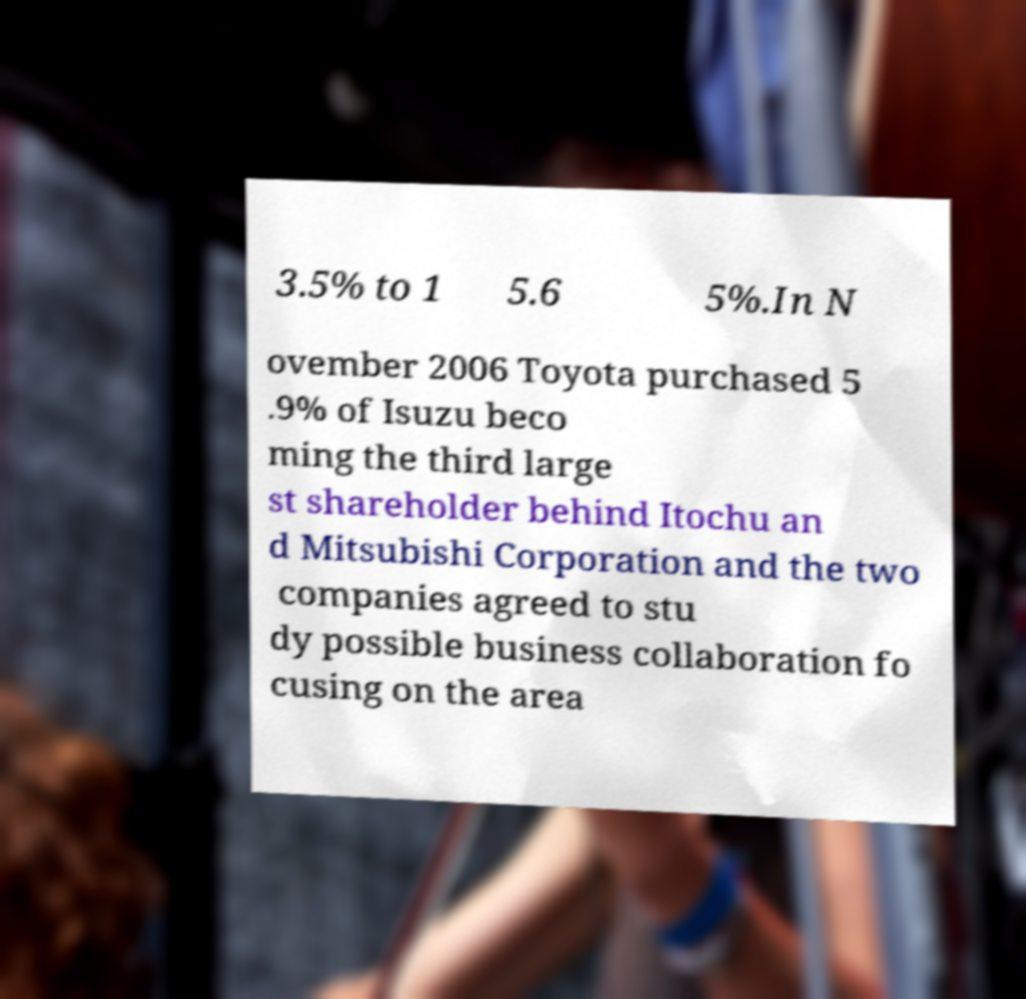Could you extract and type out the text from this image? 3.5% to 1 5.6 5%.In N ovember 2006 Toyota purchased 5 .9% of Isuzu beco ming the third large st shareholder behind Itochu an d Mitsubishi Corporation and the two companies agreed to stu dy possible business collaboration fo cusing on the area 